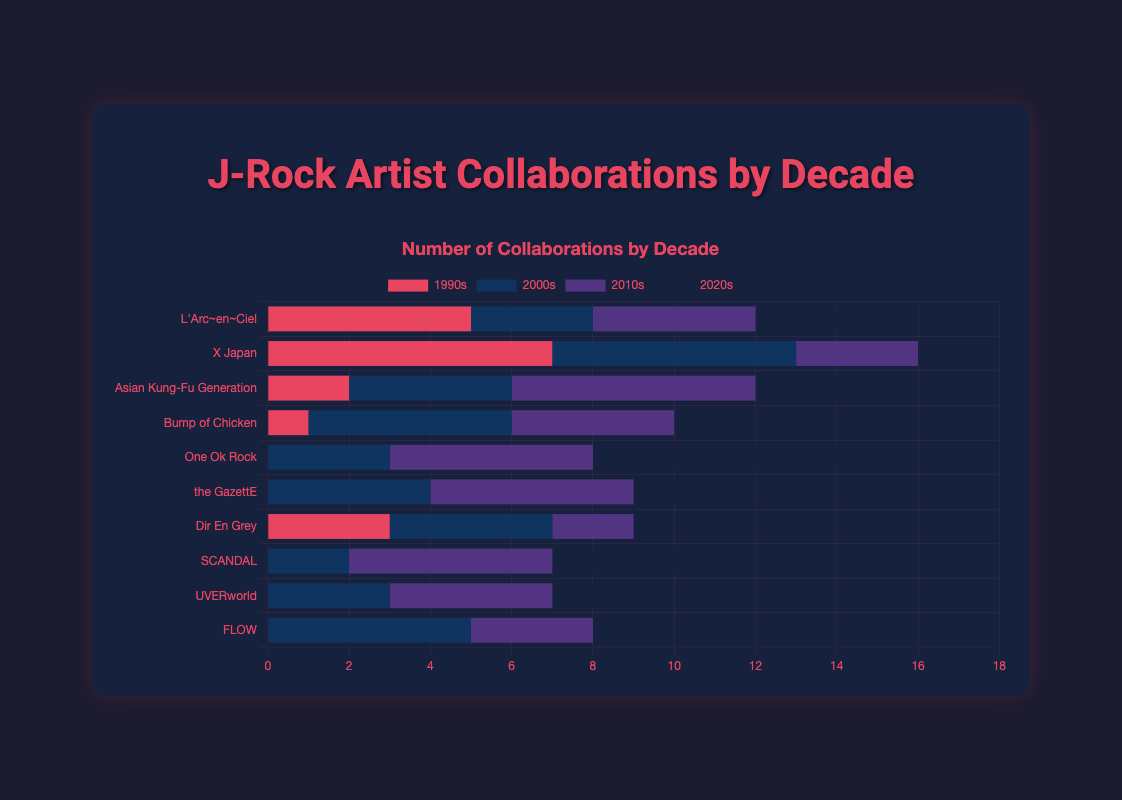Which artist had the highest number of collaborations in the 2020s? The chart shows that One Ok Rock had the highest number of collaborations in the 2020s with 6.
Answer: One Ok Rock Which artist had the smallest difference in collaborations between the 1990s and 2000s? The artists with collaboration data in both the 1990s and 2000s are L'Arc~en~Ciel, X Japan, Asian Kung-Fu Generation, Bump of Chicken, Dir En Grey. Calculate the differences: L'Arc~en~Ciel (5-3=2), X Japan (7-6=1), Asian Kung-Fu Generation (2-4=2), Bump of Chicken (1-5=4), Dir En Grey (3-4=1). Both X Japan and Dir En Grey have the smallest differences of 1.
Answer: X Japan, Dir En Grey What is the average number of collaborations in the 2010s across all artists? Sum up all the collaborations in the 2010s: (4+3+6+4+5+5+2+5+4+3)=41, and divide it by the number of artists (10) to get the average: 41/10=4.1
Answer: 4.1 How many more collaborations did X Japan have in the 1990s compared to the 2020s? X Japan had 7 collaborations in the 1990s and 1 in the 2020s. The difference is 7 - 1 = 6.
Answer: 6 Which artist's number of collaborations continuously increased or remained the same over the decades? Observing each artist's bar height across decades, only One Ok Rock’s collaborations increased or remained the same from 1990s (0) to 2000s (3), 2010s (5), and 2020s (6).
Answer: One Ok Rock Which decade had the highest total number of collaborations across all artists? Sum the collaborations of each decade: 1990s (5+7+2+1+0+0+3+0+0+0=18), 2000s (3+6+4+5+3+4+4+2+3+5=39), 2010s (4+3+6+4+5+5+2+5+4+3=41), 2020s (2+1+3+2+6+3+1+4+3+2=27). The highest total is in the 2010s with 41.
Answer: 2010s What is the difference between the total collaborations of L'Arc~en~Ciel and One Ok Rock over all decades? Sum L'Arc~en~Ciel's collaborations (5+3+4+2=14) and One Ok Rock’s collaborations (0+3+5+6=14). The difference is 0.
Answer: 0 Did any artist not have any collaborations in the 1990s? From the chart, the artists with 0 collaborations in the 1990s are One Ok Rock, the GazettE, SCANDAL, UVERworld, and FLOW.
Answer: Yes Between which decades did Asian Kung-Fu Generation see the largest increase in collaborations? Calculate the differences between each decade for Asian Kung-Fu Generation: 1990s to 2000s (4-2=2), 2000s to 2010s (6-4=2), 2010s to 2020s (3-6=-3). The largest increase is between 1990s to 2000s and 2000s to 2010s, both with an increase of 2.
Answer: 1990s to 2000s, 2000s to 2010s 